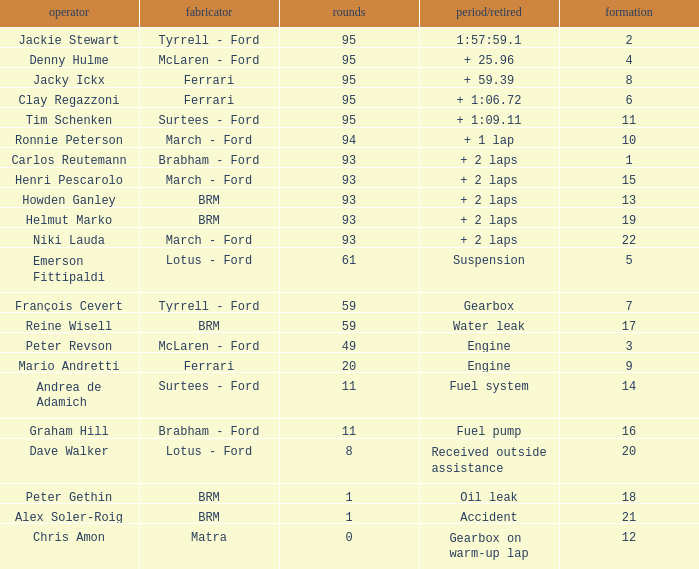How many grids does dave walker have? 1.0. 